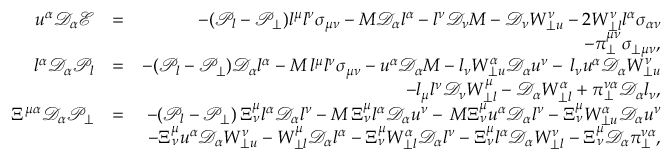Convert formula to latex. <formula><loc_0><loc_0><loc_500><loc_500>\begin{array} { r l r } { u ^ { \alpha } \mathcal { D } _ { \alpha } \mathcal { E } } & { = } & { - ( \mathcal { P } _ { l } - \mathcal { P } _ { \perp } ) l ^ { \mu } l ^ { \nu } \sigma _ { \mu \nu } - M \mathcal { D } _ { \alpha } l ^ { \alpha } - l ^ { \nu } \mathcal { D } _ { \nu } M - \mathcal { D } _ { \nu } W _ { \perp u } ^ { \nu } - 2 W _ { \perp l } ^ { \nu } l ^ { \alpha } \sigma _ { \alpha \nu } } \\ & { - \pi _ { \perp } ^ { \mu \nu } \sigma _ { \perp \mu \nu } , } \\ { l ^ { \alpha } \mathcal { D } _ { \alpha } \mathcal { P } _ { l } } & { = } & { - ( \mathcal { P } _ { l } - \mathcal { P } _ { \perp } ) \mathcal { D } _ { \alpha } l ^ { \alpha } - M \, l ^ { \mu } l ^ { \nu } \sigma _ { \mu \nu } - u ^ { \alpha } \mathcal { D } _ { \alpha } M - l _ { \nu } W _ { \perp u } ^ { \alpha } \mathcal { D } _ { \alpha } u ^ { \nu } - \, l _ { \nu } u ^ { \alpha } \mathcal { D } _ { \alpha } W _ { \perp u } ^ { \nu } } \\ & { - l _ { \mu } l ^ { \nu } \mathcal { D } _ { \nu } W _ { \perp l } ^ { \mu } - \mathcal { D } _ { \alpha } W _ { \perp l } ^ { \alpha } + \pi _ { \perp } ^ { \nu \alpha } \mathcal { D } _ { \alpha } l _ { \nu } , } \\ { \Xi ^ { \mu \alpha } \mathcal { D } _ { \alpha } \mathcal { P _ { \perp } } } & { = } & { - ( \mathcal { P } _ { l } - \mathcal { P } _ { \perp } ) \, \Xi _ { \nu } ^ { \mu } l ^ { \alpha } \mathcal { D } _ { \alpha } l ^ { \nu } - M \, \Xi _ { \nu } ^ { \mu } l ^ { \alpha } \mathcal { D } _ { \alpha } u ^ { \nu } - \, M \Xi _ { \nu } ^ { \mu } u ^ { \alpha } \mathcal { D } _ { \alpha } l ^ { \nu } - \Xi _ { \nu } ^ { \mu } W _ { \perp u } ^ { \alpha } \mathcal { D } _ { \alpha } u ^ { \nu } } \\ & { - \Xi _ { \nu } ^ { \mu } u ^ { \alpha } \mathcal { D } _ { \alpha } W _ { \perp u } ^ { \nu } - W _ { \perp l } ^ { \mu } \mathcal { D } _ { \alpha } l ^ { \alpha } - \Xi _ { \nu } ^ { \mu } W _ { \perp l } ^ { \alpha } \mathcal { D } _ { \alpha } l ^ { \nu } - \Xi _ { \nu } ^ { \mu } l ^ { \alpha } \mathcal { D } _ { \alpha } W _ { \perp l } ^ { \nu } - \Xi _ { \nu } ^ { \mu } \mathcal { D } _ { \alpha } \pi _ { \perp } ^ { \nu \alpha } , } \end{array}</formula> 